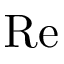Convert formula to latex. <formula><loc_0><loc_0><loc_500><loc_500>R e</formula> 